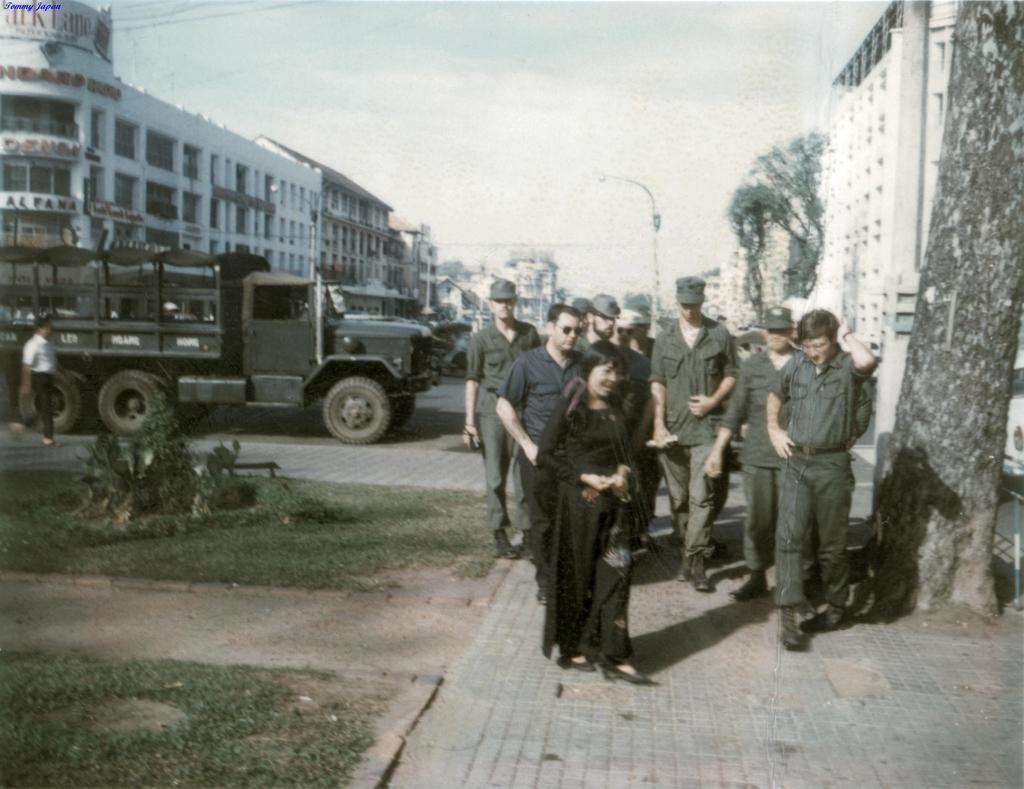In one or two sentences, can you explain what this image depicts? In this image there are a few army personnel walking on the pavement, beside them there is a tree, on the either side of the of the image there are buildings and there is a truck on the road. 